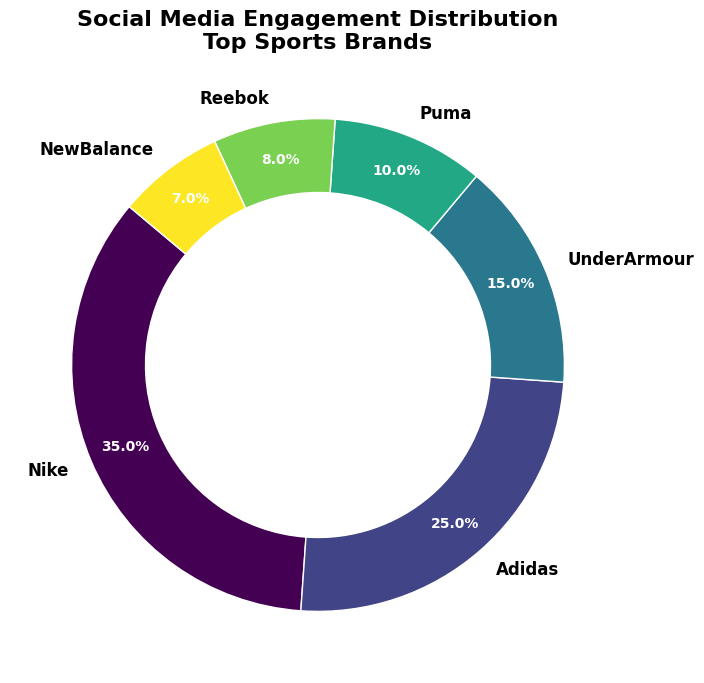Which brand has the highest social media engagement? The figure shows segments representing the social media engagement distribution for different sports brands. The brand with the largest segment represents the highest engagement. In the figure, Nike has the largest segment with 35% engagement.
Answer: Nike Which three brands have the lowest social media engagement percentages? The engagement percentages for each brand are labeled in the figure. By identifying the smallest three segments, we can determine that Reebok (8%), Puma (10%), and New Balance (7%) have the lowest engagement percentages.
Answer: Reebok, Puma, New Balance What is the combined engagement percentage of Adidas and Under Armour? The figure shows that Adidas has a 25% engagement and Under Armour has 15%. Adding these together gives the combined engagement percentage: 25% + 15% = 40%.
Answer: 40% How does Puma's engagement compare to Reebok's? By comparing the segments visually, we can see that Puma has an engagement of 10% while Reebok has 8%. Therefore, Puma's engagement is higher than Reebok's.
Answer: Puma's engagement is higher than Reebok's Which brand’s engagement is closest to New Balance in percentage? New Balance has 7% engagement. We compare this with the other brands' percentages: Nike (35%), Adidas (25%), Under Armour (15%), Puma (10%), Reebok (8%). The closest value to 7% is Reebok’s 8%.
Answer: Reebok What’s the difference in engagement between the highest and lowest brands? From the figure, Nike has the highest engagement at 35% and New Balance the lowest at 7%. The difference is calculated as 35% - 7% = 28%.
Answer: 28% If we combine the engagements of Puma, Reebok, and New Balance, how much percentage is that? Their engagement percentages are Puma (10%), Reebok (8%), and New Balance (7%). Adding these together gives: 10% + 8% + 7% = 25%.
Answer: 25% What visual clue helps to identify the leading brand in a glance? The largest segment in the ring chart immediately draws attention, indicating that Nike is the leading brand with 35% engagement.
Answer: Largest segment On the chart, how do the sizes of the segments visually indicate the proportional engagement of each brand? The size of each segment is proportional to the engagement percentage it represents. Larger segments indicate higher engagement, while smaller segments represent lower engagement. For example, Nike's large segment for 35% clearly shows it has higher engagement compared to New Balance's small segment at 7%.
Answer: Proportional segment sizes 